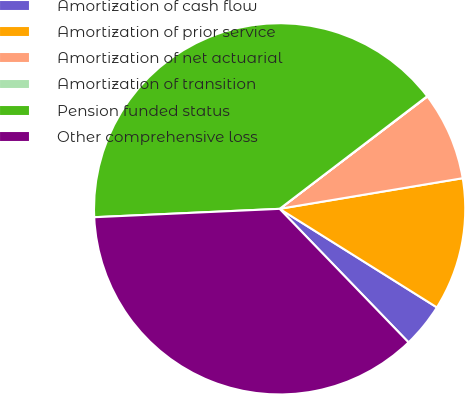Convert chart to OTSL. <chart><loc_0><loc_0><loc_500><loc_500><pie_chart><fcel>Amortization of cash flow<fcel>Amortization of prior service<fcel>Amortization of net actuarial<fcel>Amortization of transition<fcel>Pension funded status<fcel>Other comprehensive loss<nl><fcel>3.87%<fcel>11.55%<fcel>7.71%<fcel>0.03%<fcel>40.34%<fcel>36.5%<nl></chart> 